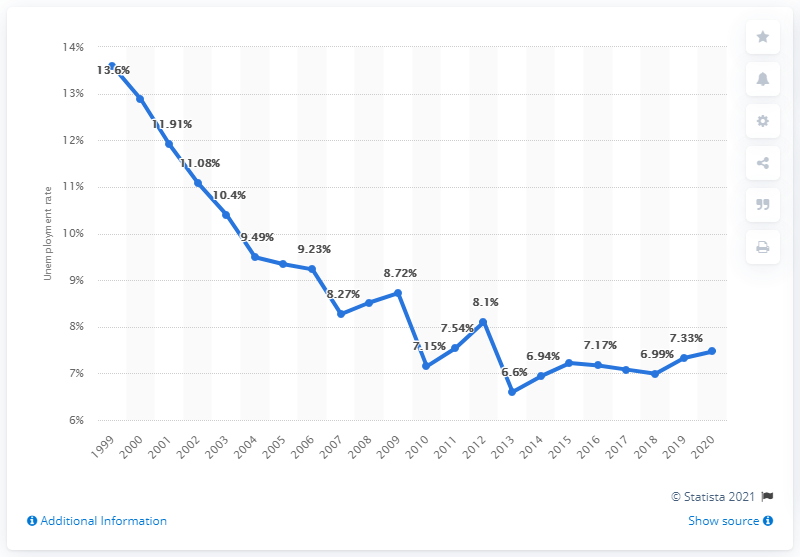Highlight a few significant elements in this photo. In 2020, the unemployment rate in Suriname was 7.47%. 